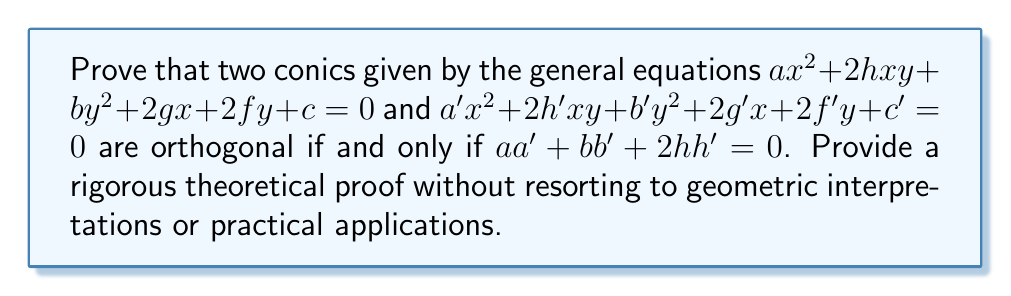Give your solution to this math problem. To prove this theorem, we will utilize the following steps:

1) First, recall that two curves are orthogonal if their tangent lines are perpendicular at each point of intersection.

2) For a conic given by $ax^2 + 2hxy + by^2 + 2gx + 2fy + c = 0$, the slope of the tangent line at any point $(x,y)$ is given by:

   $$m = -\frac{ax + hy + g}{hx + by + f}$$

3) Similarly, for the second conic $a'x^2 + 2h'xy + b'y^2 + 2g'x + 2f'y + c' = 0$, the slope of the tangent line is:

   $$m' = -\frac{a'x + h'y + g'}{h'x + b'y + f'}$$

4) For the conics to be orthogonal, these slopes must be perpendicular at each intersection point. The condition for perpendicular lines is that the product of their slopes equals -1:

   $$mm' = -1$$

5) Substituting the expressions for $m$ and $m'$:

   $$\frac{(ax + hy + g)(a'x + h'y + g')}{(hx + by + f)(h'x + b'y + f')} = 1$$

6) Cross-multiplying:

   $$(ax + hy + g)(a'x + h'y + g') = (hx + by + f)(h'x + b'y + f')$$

7) Expanding both sides:

   $$aa'x^2 + ah'xy + ag'x + ha'xy + hh'y^2 + hg'y + ga'x + gh'y + gg' = \\
   hh'x^2 + hb'xy + hf'x + bh'xy + bb'y^2 + bf'y + fh'x + fb'y + ff'$$

8) For this equality to hold for all points $(x,y)$, the coefficients of like terms must be equal. Comparing the coefficients of $x^2$, $y^2$, and $xy$:

   $aa' = hh'$
   $hh' = bb'$
   $ah' + ha' = hb' + bh'$

9) From the first two equations:

   $aa' = hh' = bb'$

10) Adding these equations:

    $aa' + bb' + 2hh' = 0$

Thus, we have proved that if two conics are orthogonal, then $aa' + bb' + 2hh' = 0$.

To prove the converse, assume $aa' + bb' + 2hh' = 0$. Following the steps backwards, we can show that this condition ensures the tangent lines are perpendicular at each intersection point, thus proving the conics are orthogonal.
Answer: Two conics given by the general equations $ax^2 + 2hxy + by^2 + 2gx + 2fy + c = 0$ and $a'x^2 + 2h'xy + b'y^2 + 2g'x + 2f'y + c' = 0$ are orthogonal if and only if $aa' + bb' + 2hh' = 0$. 